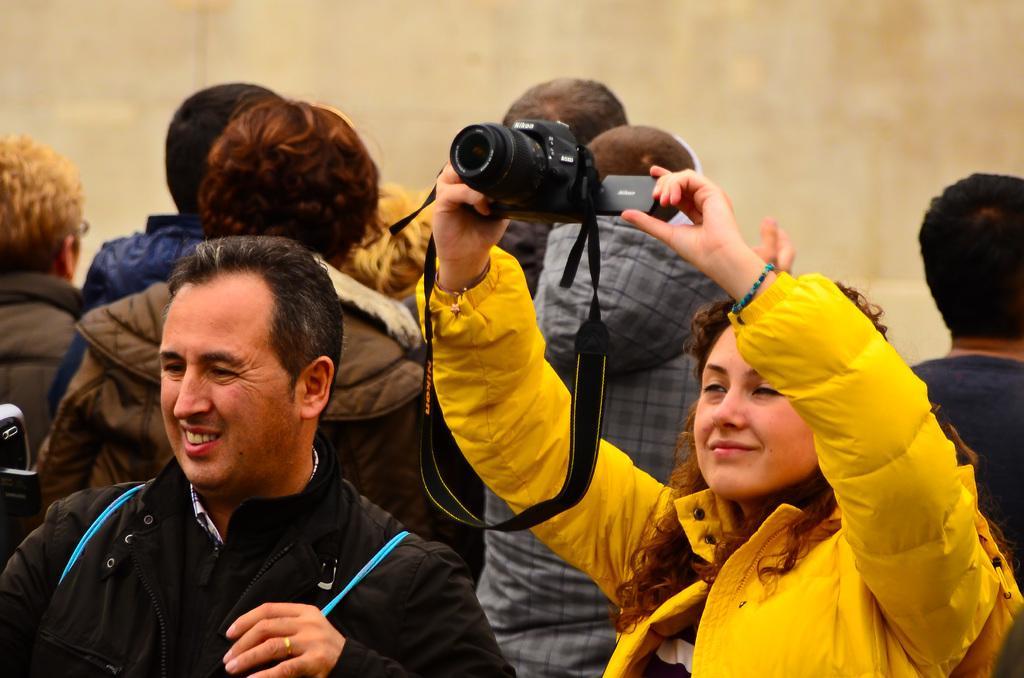Could you give a brief overview of what you see in this image? In this Picture we can see group of people are standing, In front a man wearing black jacket see straight, And a girl beside him wearing yellow puff jacket, smiling and shooting with camera. 